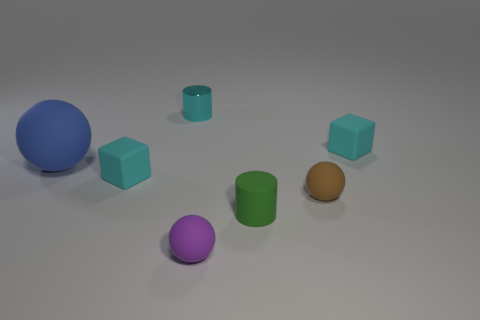Add 3 small green matte things. How many objects exist? 10 Subtract all cyan cylinders. How many cylinders are left? 1 Subtract all purple matte balls. How many balls are left? 2 Subtract 1 cyan cylinders. How many objects are left? 6 Subtract all cubes. How many objects are left? 5 Subtract 2 spheres. How many spheres are left? 1 Subtract all brown cylinders. Subtract all red cubes. How many cylinders are left? 2 Subtract all purple cubes. How many green balls are left? 0 Subtract all large red shiny cylinders. Subtract all tiny purple spheres. How many objects are left? 6 Add 5 tiny cyan cylinders. How many tiny cyan cylinders are left? 6 